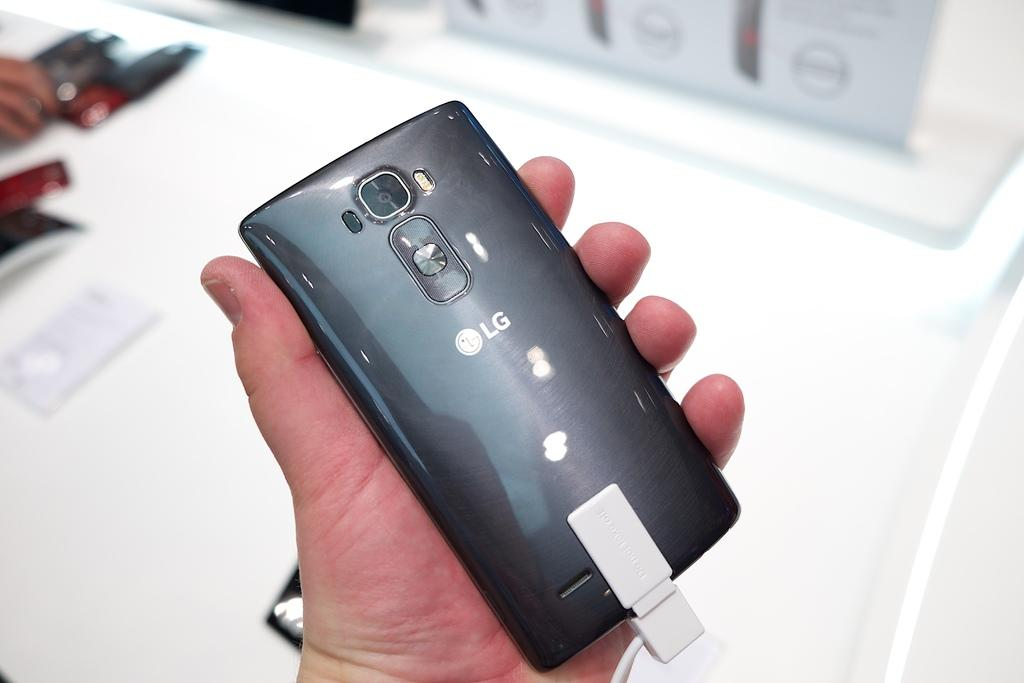<image>
Provide a brief description of the given image. A person is holding a LG phone at a display counter. 